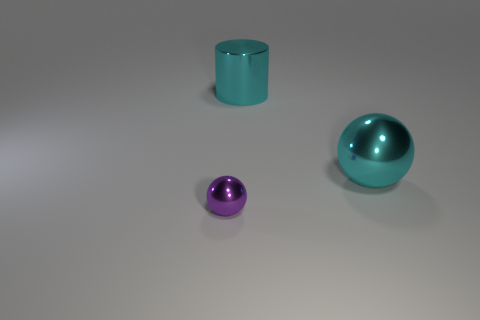The metal object that is both in front of the big cyan cylinder and behind the purple metal ball has what shape?
Offer a very short reply. Sphere. Are there any other spheres that have the same color as the small sphere?
Your answer should be very brief. No. Are there any green matte cylinders?
Offer a terse response. No. What is the color of the shiny sphere that is behind the tiny sphere?
Provide a succinct answer. Cyan. Do the purple metal object and the metallic ball that is to the right of the small purple sphere have the same size?
Ensure brevity in your answer.  No. What size is the thing that is behind the small purple metal ball and on the left side of the cyan shiny ball?
Your answer should be compact. Large. Is there a tiny sphere made of the same material as the cyan cylinder?
Offer a very short reply. Yes. There is a small purple thing; what shape is it?
Make the answer very short. Sphere. Do the purple ball and the cyan cylinder have the same size?
Keep it short and to the point. No. How many other objects are there of the same shape as the tiny object?
Ensure brevity in your answer.  1. 